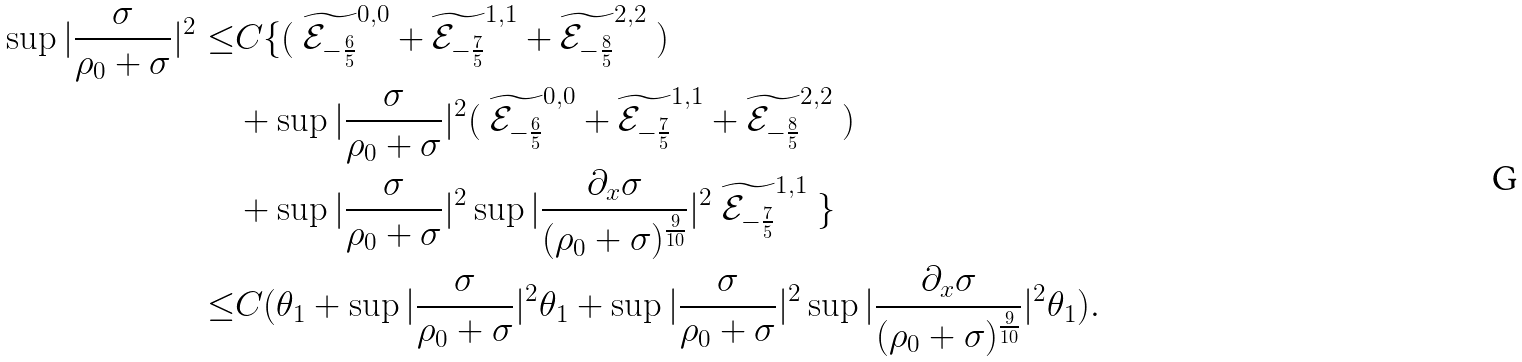Convert formula to latex. <formula><loc_0><loc_0><loc_500><loc_500>\sup | \frac { \sigma } { \rho _ { 0 } + \sigma } | ^ { 2 } \leq & C \{ ( \text { } \widetilde { \mathcal { E } _ { - \frac { 6 } { 5 } } } ^ { 0 , 0 } + \widetilde { \mathcal { E } _ { - \frac { 7 } { 5 } } } ^ { 1 , 1 } + \widetilde { \mathcal { E } _ { - \frac { 8 } { 5 } } } ^ { 2 , 2 } \text { } ) \\ & + \sup | \frac { \sigma } { \rho _ { 0 } + \sigma } | ^ { 2 } ( \text { } \widetilde { \mathcal { E } _ { - \frac { 6 } { 5 } } } ^ { 0 , 0 } + \widetilde { \mathcal { E } _ { - \frac { 7 } { 5 } } } ^ { 1 , 1 } + \widetilde { \mathcal { E } _ { - \frac { 8 } { 5 } } } ^ { 2 , 2 } \text { } ) \\ & + \sup | \frac { \sigma } { \rho _ { 0 } + \sigma } | ^ { 2 } \sup | \frac { \partial _ { x } \sigma } { ( \rho _ { 0 } + \sigma ) ^ { \frac { 9 } { 1 0 } } } | ^ { 2 } \text { } \widetilde { \mathcal { E } _ { - \frac { 7 } { 5 } } } ^ { 1 , 1 } \text { } \} \\ \leq & C ( \theta _ { 1 } + \sup | \frac { \sigma } { \rho _ { 0 } + \sigma } | ^ { 2 } \theta _ { 1 } + \sup | \frac { \sigma } { \rho _ { 0 } + \sigma } | ^ { 2 } \sup | \frac { \partial _ { x } \sigma } { ( \rho _ { 0 } + \sigma ) ^ { \frac { 9 } { 1 0 } } } | ^ { 2 } \theta _ { 1 } ) .</formula> 